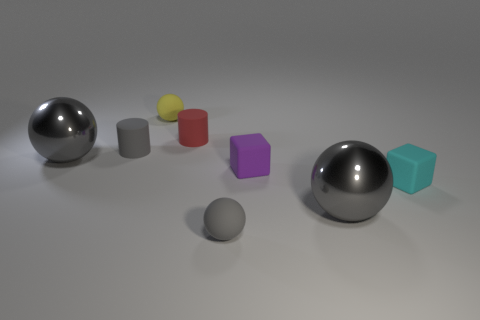Is the number of small gray balls behind the red matte cylinder the same as the number of tiny blue objects?
Offer a very short reply. Yes. There is a purple thing that is made of the same material as the red cylinder; what shape is it?
Your answer should be compact. Cube. How many metal things are yellow things or large gray balls?
Ensure brevity in your answer.  2. What number of red matte objects are behind the tiny matte cylinder left of the red matte thing?
Make the answer very short. 1. How many small cyan things are the same material as the tiny purple block?
Give a very brief answer. 1. What number of large objects are cyan blocks or blue matte spheres?
Your answer should be very brief. 0. What shape is the gray thing that is both on the left side of the small yellow sphere and in front of the tiny gray matte cylinder?
Offer a very short reply. Sphere. Are the small red cylinder and the tiny cyan object made of the same material?
Your answer should be very brief. Yes. What is the color of the cylinder that is the same size as the red matte thing?
Keep it short and to the point. Gray. There is a object that is both in front of the gray rubber cylinder and on the left side of the gray matte ball; what is its color?
Offer a terse response. Gray. 